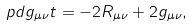<formula> <loc_0><loc_0><loc_500><loc_500>\ p d { g _ { \mu \nu } } { t } = - 2 R _ { \mu \nu } + 2 g _ { \mu \nu } ,</formula> 